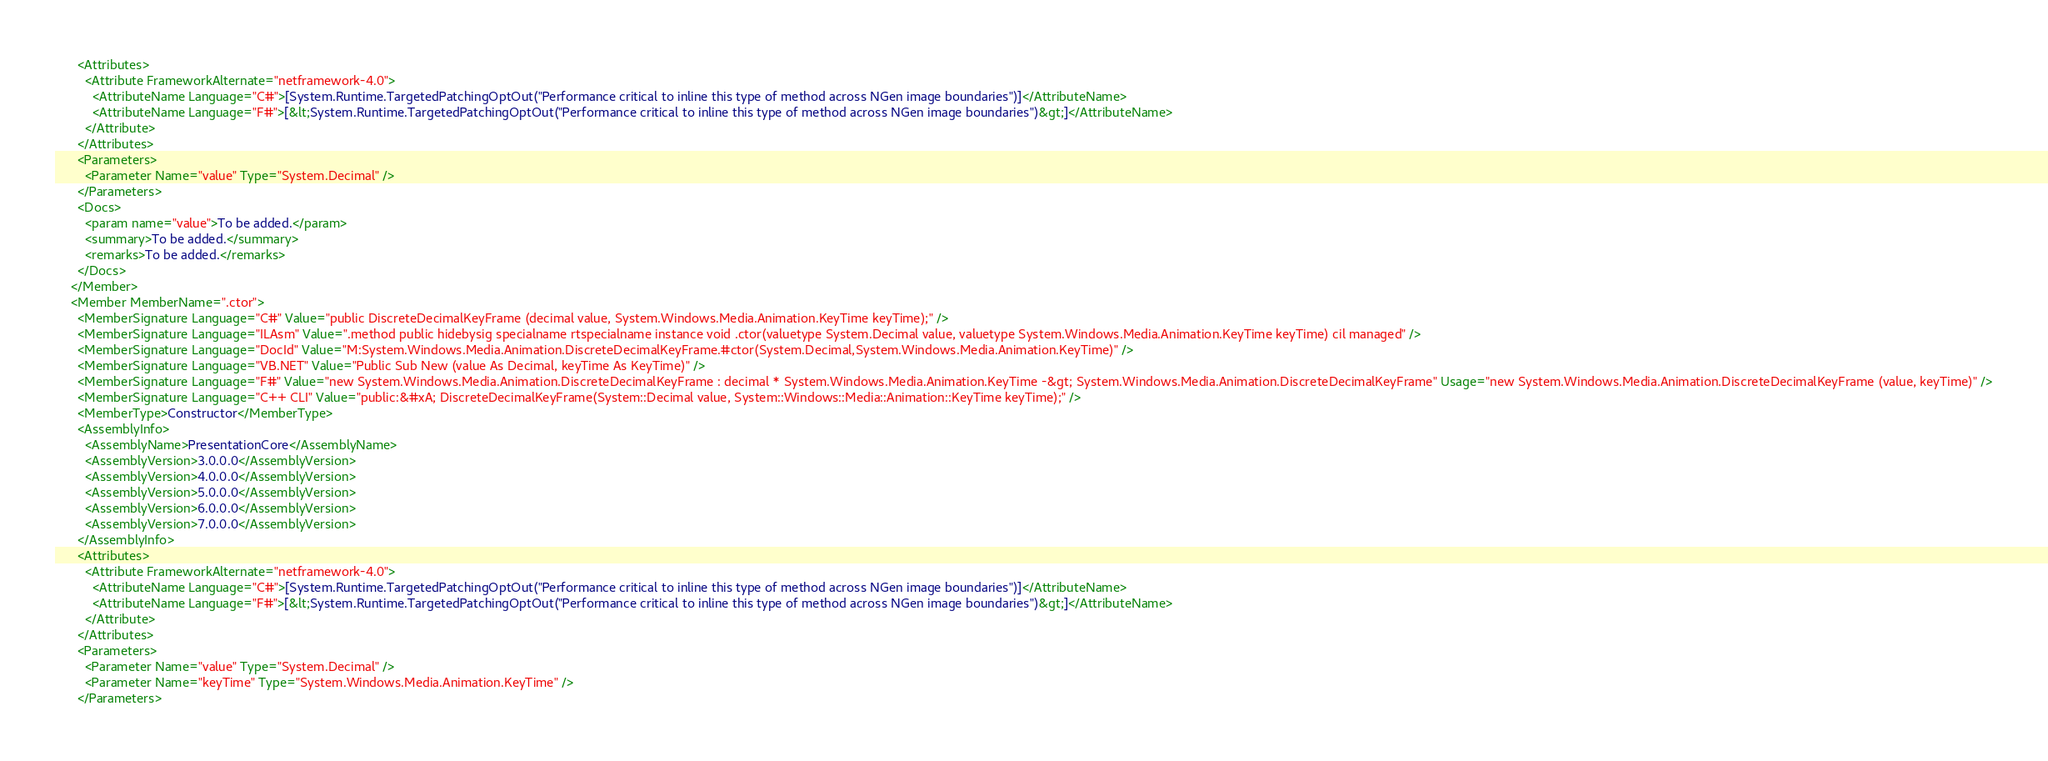<code> <loc_0><loc_0><loc_500><loc_500><_XML_>      <Attributes>
        <Attribute FrameworkAlternate="netframework-4.0">
          <AttributeName Language="C#">[System.Runtime.TargetedPatchingOptOut("Performance critical to inline this type of method across NGen image boundaries")]</AttributeName>
          <AttributeName Language="F#">[&lt;System.Runtime.TargetedPatchingOptOut("Performance critical to inline this type of method across NGen image boundaries")&gt;]</AttributeName>
        </Attribute>
      </Attributes>
      <Parameters>
        <Parameter Name="value" Type="System.Decimal" />
      </Parameters>
      <Docs>
        <param name="value">To be added.</param>
        <summary>To be added.</summary>
        <remarks>To be added.</remarks>
      </Docs>
    </Member>
    <Member MemberName=".ctor">
      <MemberSignature Language="C#" Value="public DiscreteDecimalKeyFrame (decimal value, System.Windows.Media.Animation.KeyTime keyTime);" />
      <MemberSignature Language="ILAsm" Value=".method public hidebysig specialname rtspecialname instance void .ctor(valuetype System.Decimal value, valuetype System.Windows.Media.Animation.KeyTime keyTime) cil managed" />
      <MemberSignature Language="DocId" Value="M:System.Windows.Media.Animation.DiscreteDecimalKeyFrame.#ctor(System.Decimal,System.Windows.Media.Animation.KeyTime)" />
      <MemberSignature Language="VB.NET" Value="Public Sub New (value As Decimal, keyTime As KeyTime)" />
      <MemberSignature Language="F#" Value="new System.Windows.Media.Animation.DiscreteDecimalKeyFrame : decimal * System.Windows.Media.Animation.KeyTime -&gt; System.Windows.Media.Animation.DiscreteDecimalKeyFrame" Usage="new System.Windows.Media.Animation.DiscreteDecimalKeyFrame (value, keyTime)" />
      <MemberSignature Language="C++ CLI" Value="public:&#xA; DiscreteDecimalKeyFrame(System::Decimal value, System::Windows::Media::Animation::KeyTime keyTime);" />
      <MemberType>Constructor</MemberType>
      <AssemblyInfo>
        <AssemblyName>PresentationCore</AssemblyName>
        <AssemblyVersion>3.0.0.0</AssemblyVersion>
        <AssemblyVersion>4.0.0.0</AssemblyVersion>
        <AssemblyVersion>5.0.0.0</AssemblyVersion>
        <AssemblyVersion>6.0.0.0</AssemblyVersion>
        <AssemblyVersion>7.0.0.0</AssemblyVersion>
      </AssemblyInfo>
      <Attributes>
        <Attribute FrameworkAlternate="netframework-4.0">
          <AttributeName Language="C#">[System.Runtime.TargetedPatchingOptOut("Performance critical to inline this type of method across NGen image boundaries")]</AttributeName>
          <AttributeName Language="F#">[&lt;System.Runtime.TargetedPatchingOptOut("Performance critical to inline this type of method across NGen image boundaries")&gt;]</AttributeName>
        </Attribute>
      </Attributes>
      <Parameters>
        <Parameter Name="value" Type="System.Decimal" />
        <Parameter Name="keyTime" Type="System.Windows.Media.Animation.KeyTime" />
      </Parameters></code> 